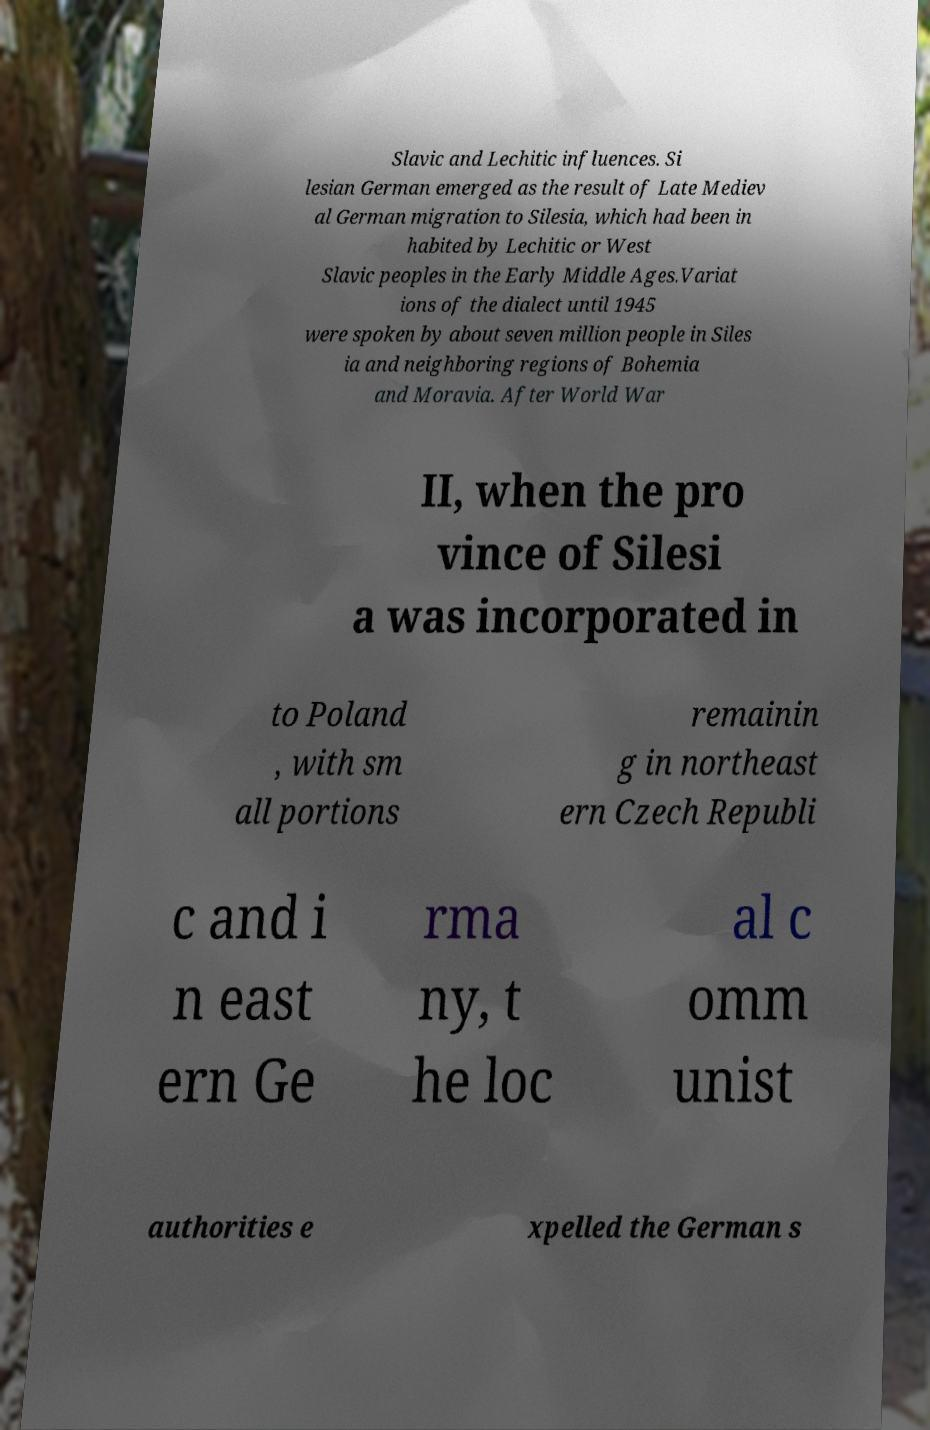I need the written content from this picture converted into text. Can you do that? Slavic and Lechitic influences. Si lesian German emerged as the result of Late Mediev al German migration to Silesia, which had been in habited by Lechitic or West Slavic peoples in the Early Middle Ages.Variat ions of the dialect until 1945 were spoken by about seven million people in Siles ia and neighboring regions of Bohemia and Moravia. After World War II, when the pro vince of Silesi a was incorporated in to Poland , with sm all portions remainin g in northeast ern Czech Republi c and i n east ern Ge rma ny, t he loc al c omm unist authorities e xpelled the German s 